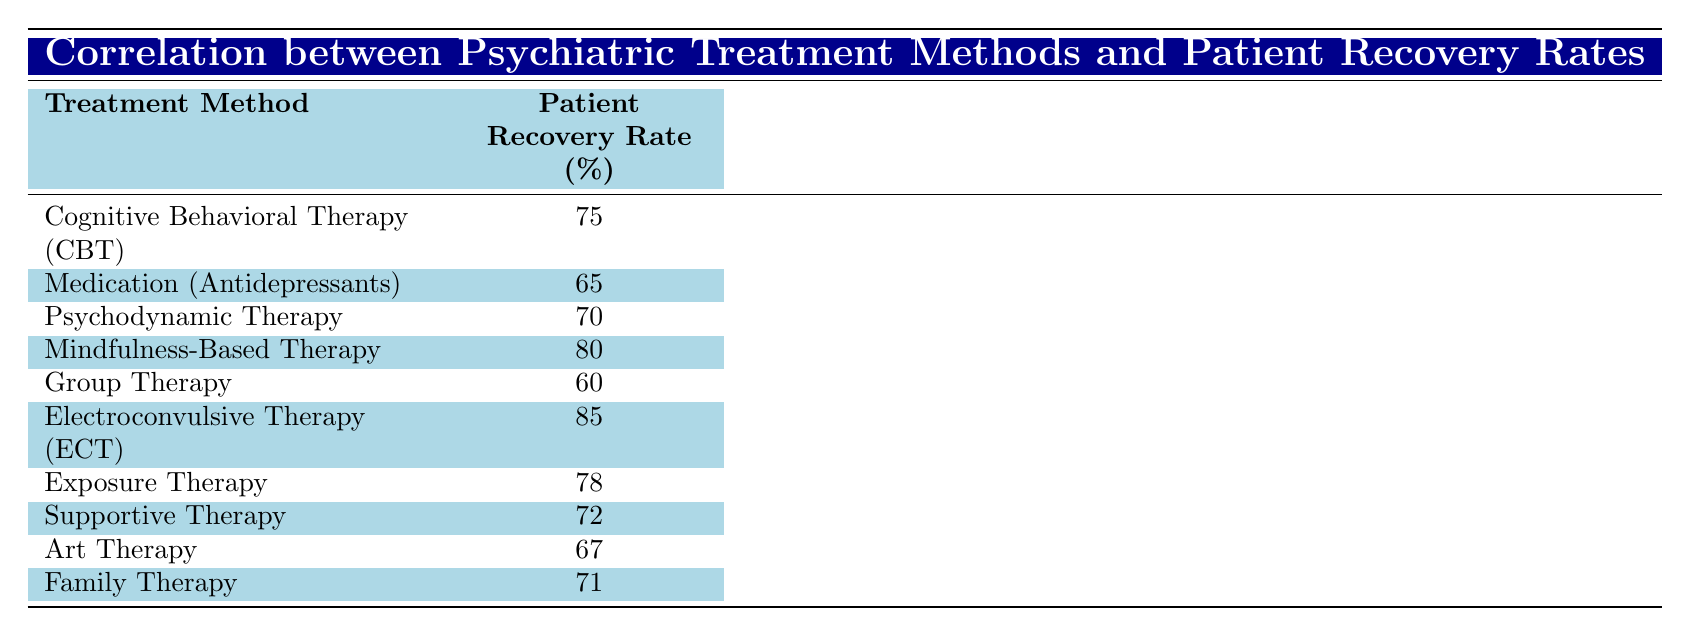What is the patient recovery rate for Cognitive Behavioral Therapy (CBT)? The table directly lists the recovery rate for Cognitive Behavioral Therapy (CBT) as 75%.
Answer: 75% Which treatment method has the highest patient recovery rate? The highest recovery rate in the table is 85%, which corresponds to Electroconvulsive Therapy (ECT).
Answer: Electroconvulsive Therapy (ECT) What is the average patient recovery rate for Art Therapy and Psychodynamic Therapy? The recovery rates for Art Therapy and Psychodynamic Therapy are 67% and 70%, respectively. To find the average: (67 + 70) / 2 = 68.5%.
Answer: 68.5% Is the patient recovery rate for Group Therapy greater than that for Medication (Antidepressants)? The recovery rate for Group Therapy is 60%, and for Medication (Antidepressants), it is 65%. Since 60% is not greater than 65%, the answer is no.
Answer: No What is the difference in patient recovery rates between Mindfulness-Based Therapy and Exposure Therapy? The recovery rate for Mindfulness-Based Therapy is 80%, and for Exposure Therapy, it is 78%. The difference is 80 - 78 = 2%.
Answer: 2% List the treatment methods that have a patient recovery rate of 70% or more. The treatment methods that have a recovery rate of 70% or more are: Cognitive Behavioral Therapy (CBT) at 75%, Mindfulness-Based Therapy at 80%, Electroconvulsive Therapy (ECT) at 85%, and Exposure Therapy at 78%.
Answer: CBT, Mindfulness-Based Therapy, ECT, Exposure Therapy Which treatment method has a recovery rate below 70%? According to the table, both Group Therapy (60%) and Medication (Antidepressants) (65%) have recovery rates below 70%.
Answer: Group Therapy, Medication (Antidepressants) If you rank all the treatment methods from highest to lowest recovery rates, what would be the rank of Family Therapy? Family Therapy has a recovery rate of 71%. When ranked among all methods, Family Therapy is in the 6th position out of 10 treatments.
Answer: 6th 